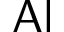Convert formula to latex. <formula><loc_0><loc_0><loc_500><loc_500>A l</formula> 